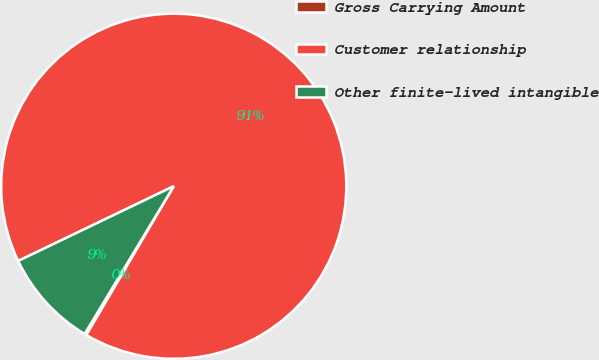<chart> <loc_0><loc_0><loc_500><loc_500><pie_chart><fcel>Gross Carrying Amount<fcel>Customer relationship<fcel>Other finite-lived intangible<nl><fcel>0.19%<fcel>90.57%<fcel>9.23%<nl></chart> 